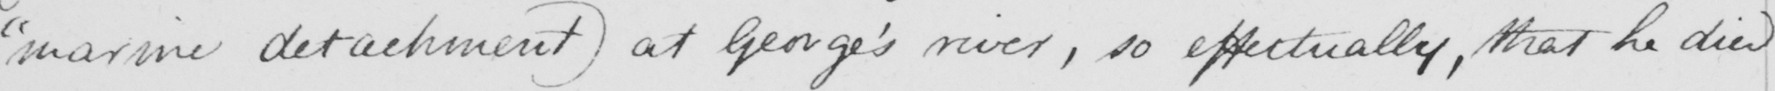Can you read and transcribe this handwriting? " marine detachment )  at George ' s river , so effectually , that he died 